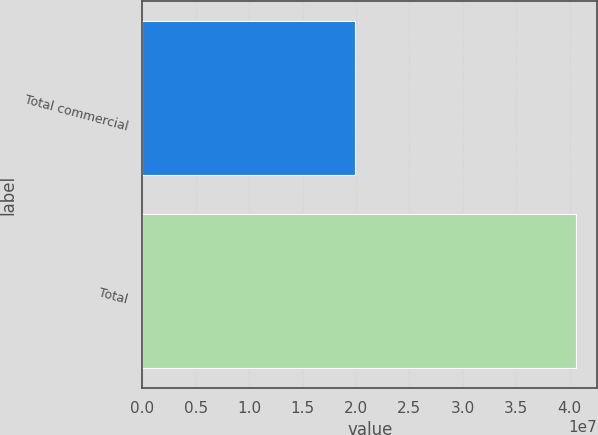Convert chart to OTSL. <chart><loc_0><loc_0><loc_500><loc_500><bar_chart><fcel>Total commercial<fcel>Total<nl><fcel>1.9897e+07<fcel>4.05645e+07<nl></chart> 